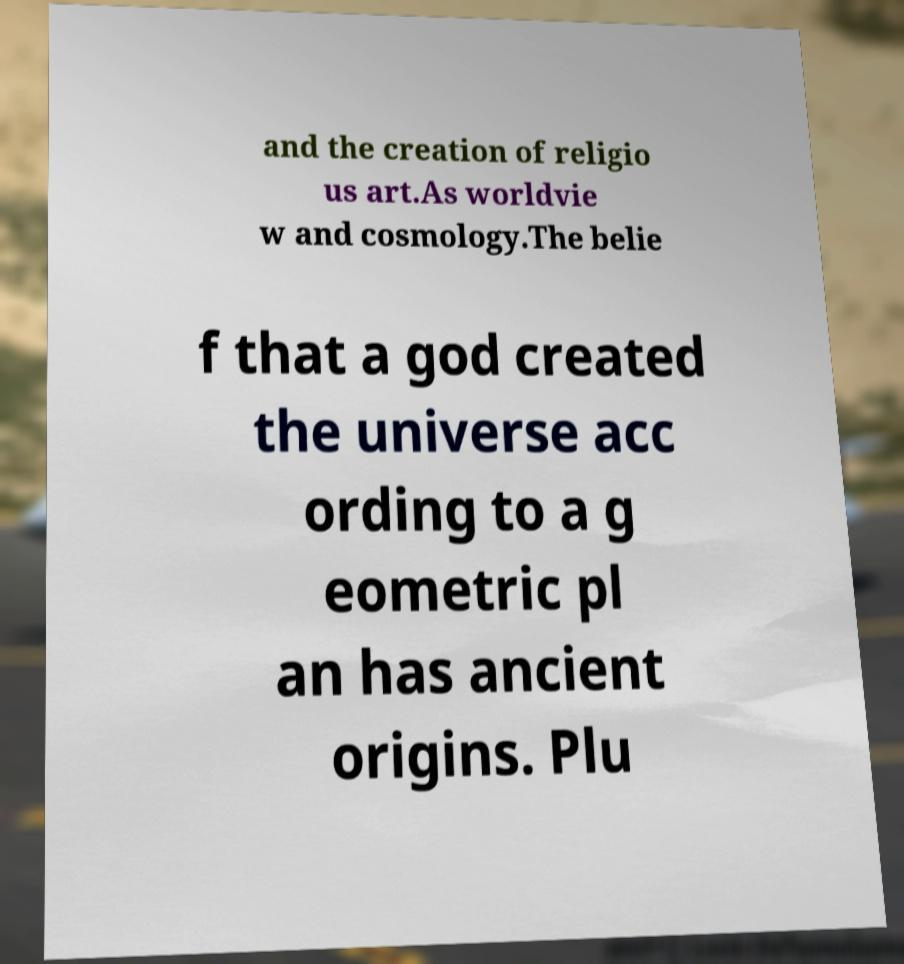I need the written content from this picture converted into text. Can you do that? and the creation of religio us art.As worldvie w and cosmology.The belie f that a god created the universe acc ording to a g eometric pl an has ancient origins. Plu 